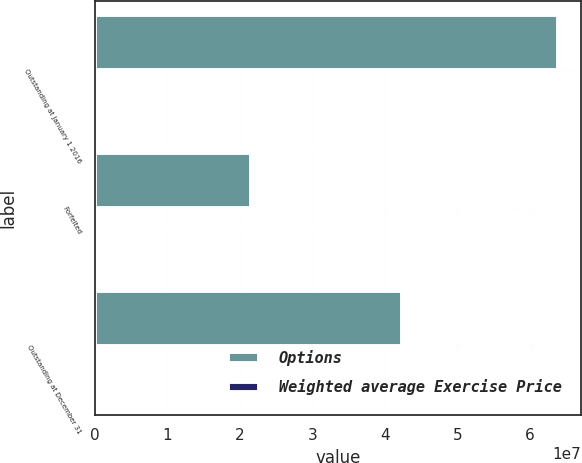Convert chart to OTSL. <chart><loc_0><loc_0><loc_500><loc_500><stacked_bar_chart><ecel><fcel>Outstanding at January 1 2016<fcel>Forfeited<fcel>Outstanding at December 31<nl><fcel>Options<fcel>6.38755e+07<fcel>2.15182e+07<fcel>4.23573e+07<nl><fcel>Weighted average Exercise Price<fcel>49.18<fcel>46.45<fcel>50.57<nl></chart> 